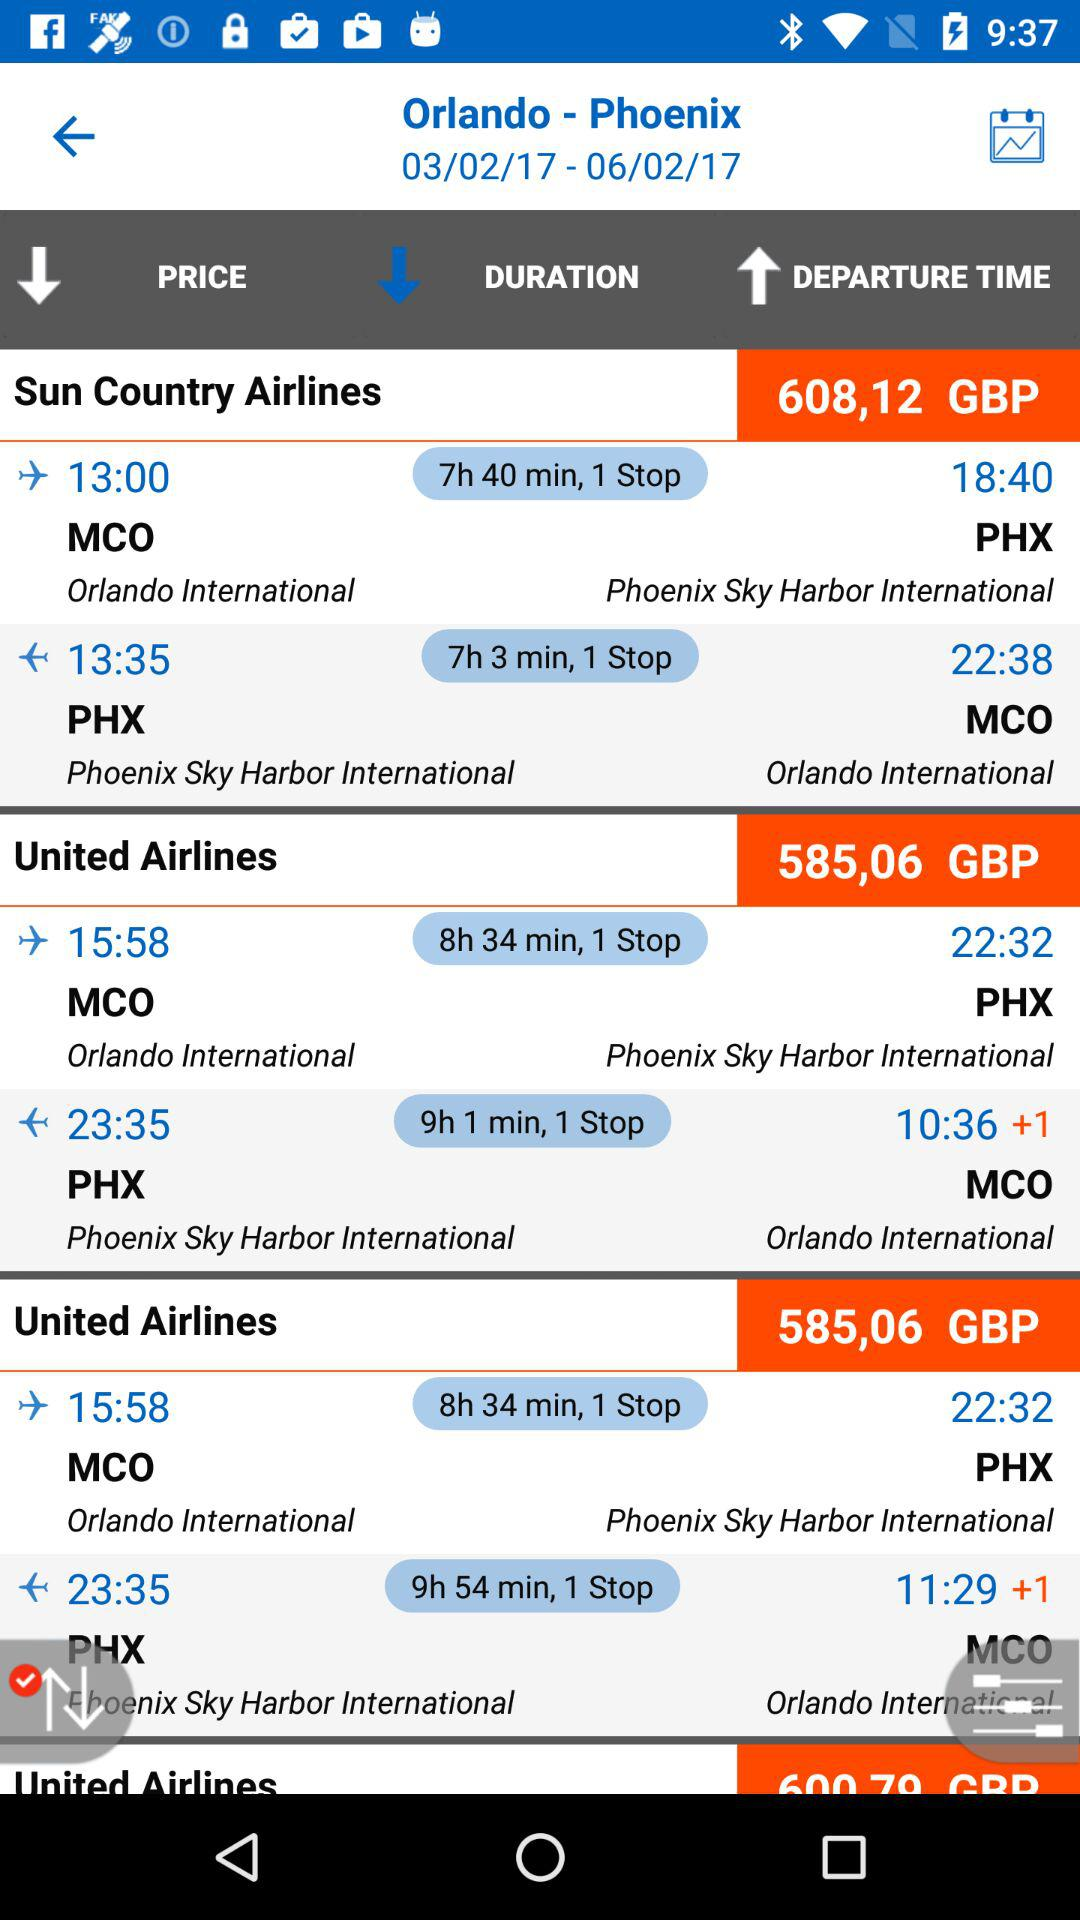What is the number of stops for Sun Country Airlines flight from MCO to PHX? The number of stops is 1. 